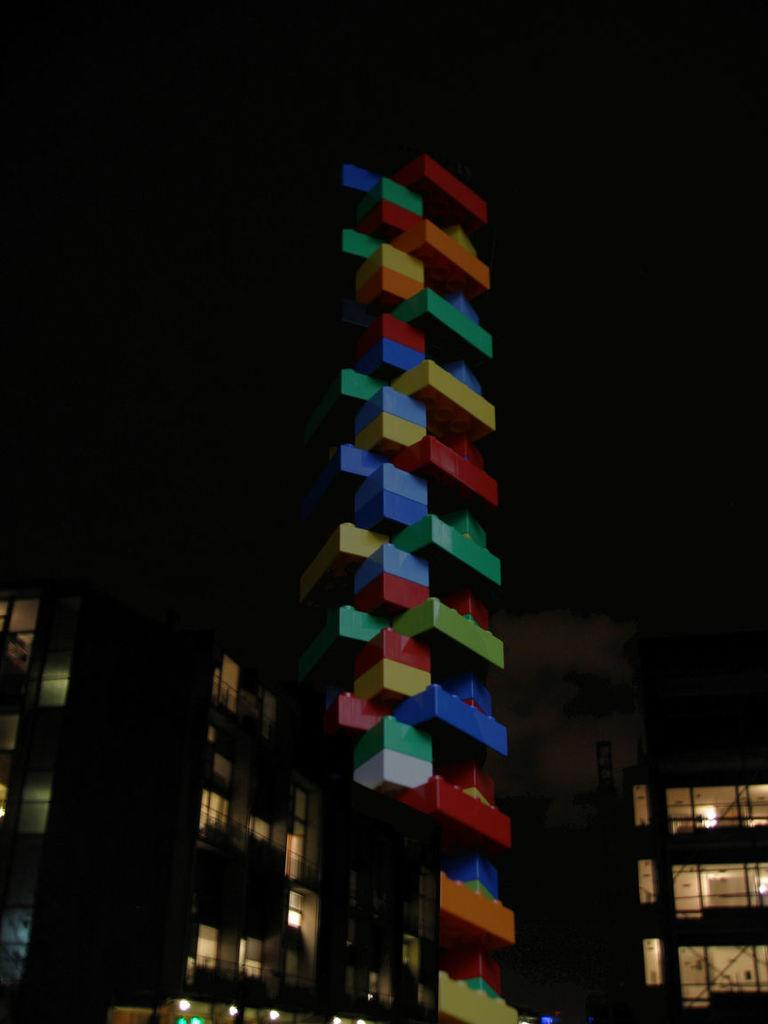What type of structures can be seen in the image? There are buildings in the image. How would you describe the lighting or color of the background in the image? The background of the image is dark. What level of expertise does the beginner have with quartz in the image? There is no mention of a beginner or quartz in the image, so this question cannot be answered. 